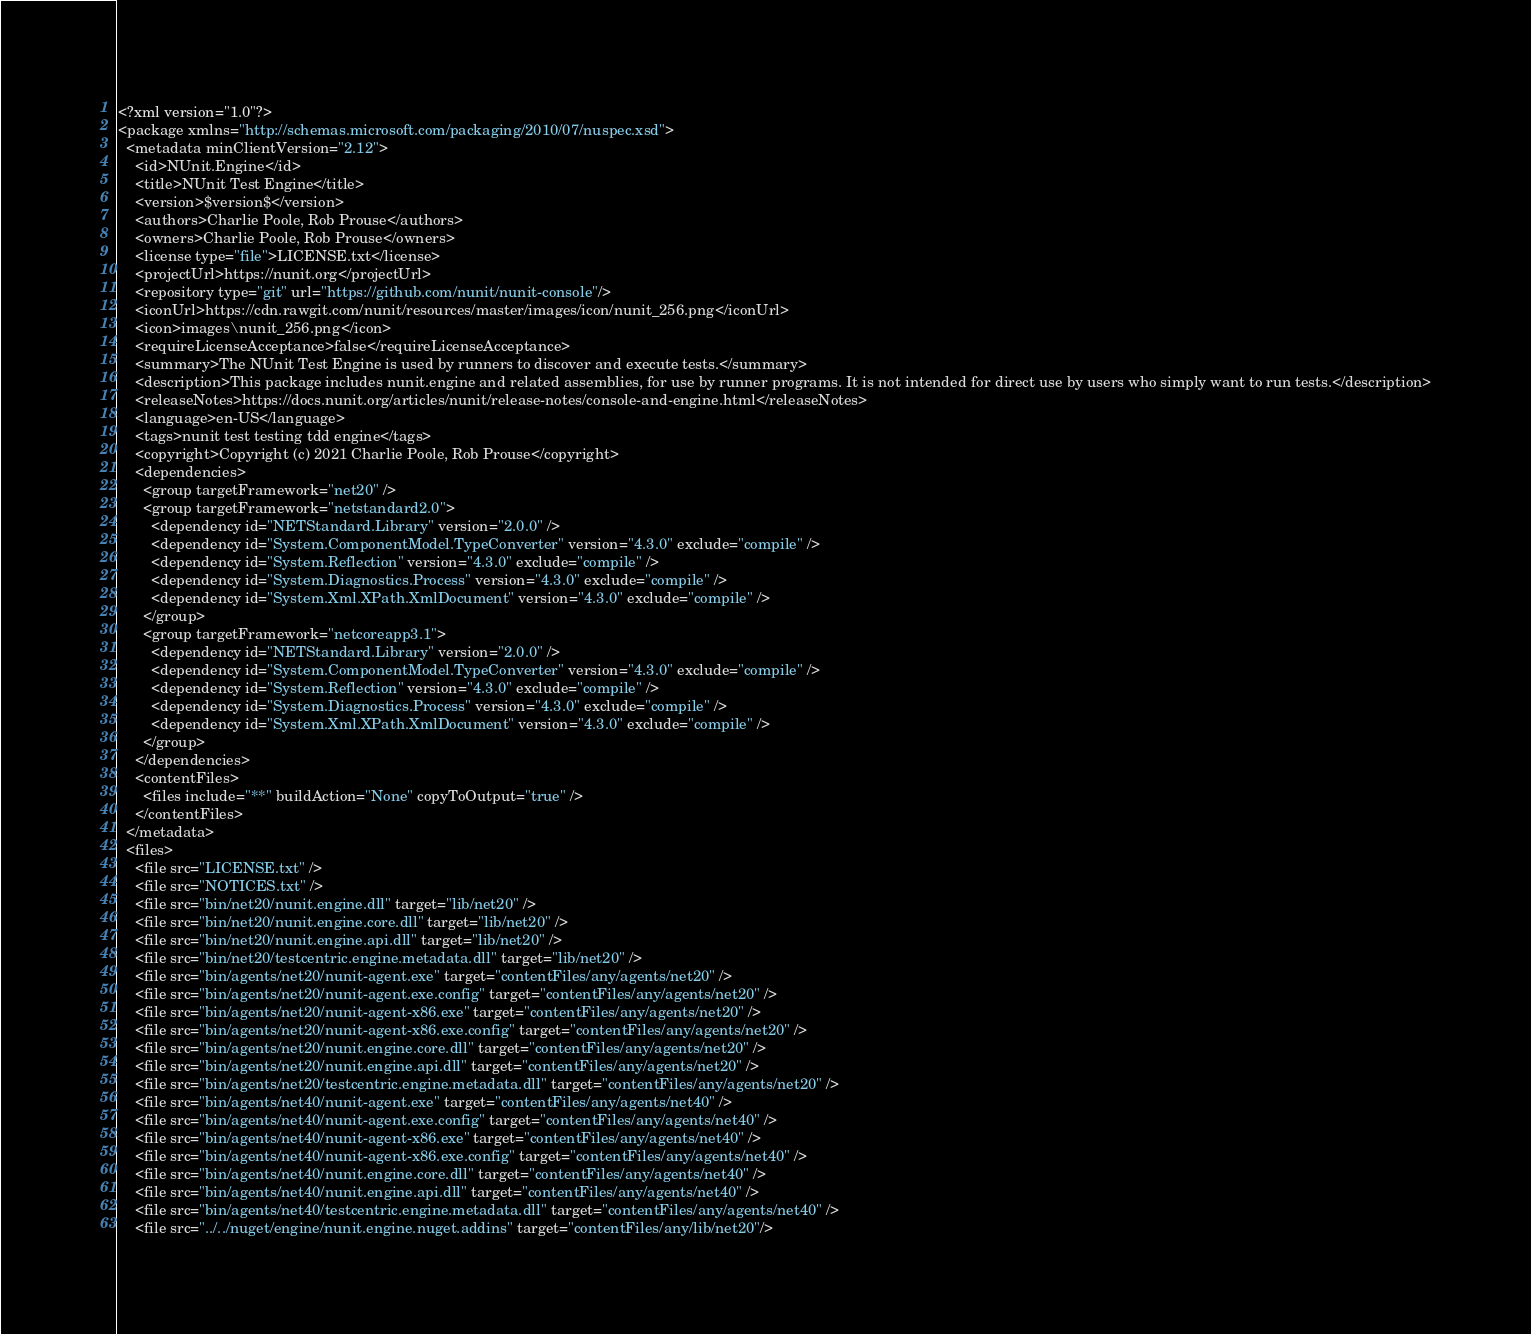<code> <loc_0><loc_0><loc_500><loc_500><_XML_><?xml version="1.0"?>
<package xmlns="http://schemas.microsoft.com/packaging/2010/07/nuspec.xsd">
  <metadata minClientVersion="2.12">
    <id>NUnit.Engine</id>
    <title>NUnit Test Engine</title>
    <version>$version$</version>
    <authors>Charlie Poole, Rob Prouse</authors>
    <owners>Charlie Poole, Rob Prouse</owners>
    <license type="file">LICENSE.txt</license>
    <projectUrl>https://nunit.org</projectUrl>
    <repository type="git" url="https://github.com/nunit/nunit-console"/>
    <iconUrl>https://cdn.rawgit.com/nunit/resources/master/images/icon/nunit_256.png</iconUrl>
    <icon>images\nunit_256.png</icon>
    <requireLicenseAcceptance>false</requireLicenseAcceptance>
    <summary>The NUnit Test Engine is used by runners to discover and execute tests.</summary>
    <description>This package includes nunit.engine and related assemblies, for use by runner programs. It is not intended for direct use by users who simply want to run tests.</description>
    <releaseNotes>https://docs.nunit.org/articles/nunit/release-notes/console-and-engine.html</releaseNotes>
    <language>en-US</language>
    <tags>nunit test testing tdd engine</tags>
    <copyright>Copyright (c) 2021 Charlie Poole, Rob Prouse</copyright>
    <dependencies>
      <group targetFramework="net20" />
      <group targetFramework="netstandard2.0">
        <dependency id="NETStandard.Library" version="2.0.0" />
        <dependency id="System.ComponentModel.TypeConverter" version="4.3.0" exclude="compile" />
        <dependency id="System.Reflection" version="4.3.0" exclude="compile" />
        <dependency id="System.Diagnostics.Process" version="4.3.0" exclude="compile" />
        <dependency id="System.Xml.XPath.XmlDocument" version="4.3.0" exclude="compile" />
      </group>
      <group targetFramework="netcoreapp3.1">
        <dependency id="NETStandard.Library" version="2.0.0" />
        <dependency id="System.ComponentModel.TypeConverter" version="4.3.0" exclude="compile" />
        <dependency id="System.Reflection" version="4.3.0" exclude="compile" />
        <dependency id="System.Diagnostics.Process" version="4.3.0" exclude="compile" />
        <dependency id="System.Xml.XPath.XmlDocument" version="4.3.0" exclude="compile" />
      </group>
    </dependencies>
    <contentFiles>
      <files include="**" buildAction="None" copyToOutput="true" />
    </contentFiles>
  </metadata>
  <files>
    <file src="LICENSE.txt" />
    <file src="NOTICES.txt" />
    <file src="bin/net20/nunit.engine.dll" target="lib/net20" />
    <file src="bin/net20/nunit.engine.core.dll" target="lib/net20" />
    <file src="bin/net20/nunit.engine.api.dll" target="lib/net20" />
    <file src="bin/net20/testcentric.engine.metadata.dll" target="lib/net20" />
    <file src="bin/agents/net20/nunit-agent.exe" target="contentFiles/any/agents/net20" />
    <file src="bin/agents/net20/nunit-agent.exe.config" target="contentFiles/any/agents/net20" />
    <file src="bin/agents/net20/nunit-agent-x86.exe" target="contentFiles/any/agents/net20" />
    <file src="bin/agents/net20/nunit-agent-x86.exe.config" target="contentFiles/any/agents/net20" />
    <file src="bin/agents/net20/nunit.engine.core.dll" target="contentFiles/any/agents/net20" />
    <file src="bin/agents/net20/nunit.engine.api.dll" target="contentFiles/any/agents/net20" />
    <file src="bin/agents/net20/testcentric.engine.metadata.dll" target="contentFiles/any/agents/net20" />
    <file src="bin/agents/net40/nunit-agent.exe" target="contentFiles/any/agents/net40" />
    <file src="bin/agents/net40/nunit-agent.exe.config" target="contentFiles/any/agents/net40" />
    <file src="bin/agents/net40/nunit-agent-x86.exe" target="contentFiles/any/agents/net40" />
    <file src="bin/agents/net40/nunit-agent-x86.exe.config" target="contentFiles/any/agents/net40" />
    <file src="bin/agents/net40/nunit.engine.core.dll" target="contentFiles/any/agents/net40" />
    <file src="bin/agents/net40/nunit.engine.api.dll" target="contentFiles/any/agents/net40" />
    <file src="bin/agents/net40/testcentric.engine.metadata.dll" target="contentFiles/any/agents/net40" />
    <file src="../../nuget/engine/nunit.engine.nuget.addins" target="contentFiles/any/lib/net20"/></code> 